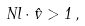Convert formula to latex. <formula><loc_0><loc_0><loc_500><loc_500>N l \cdot \hat { v } > 1 \, ,</formula> 